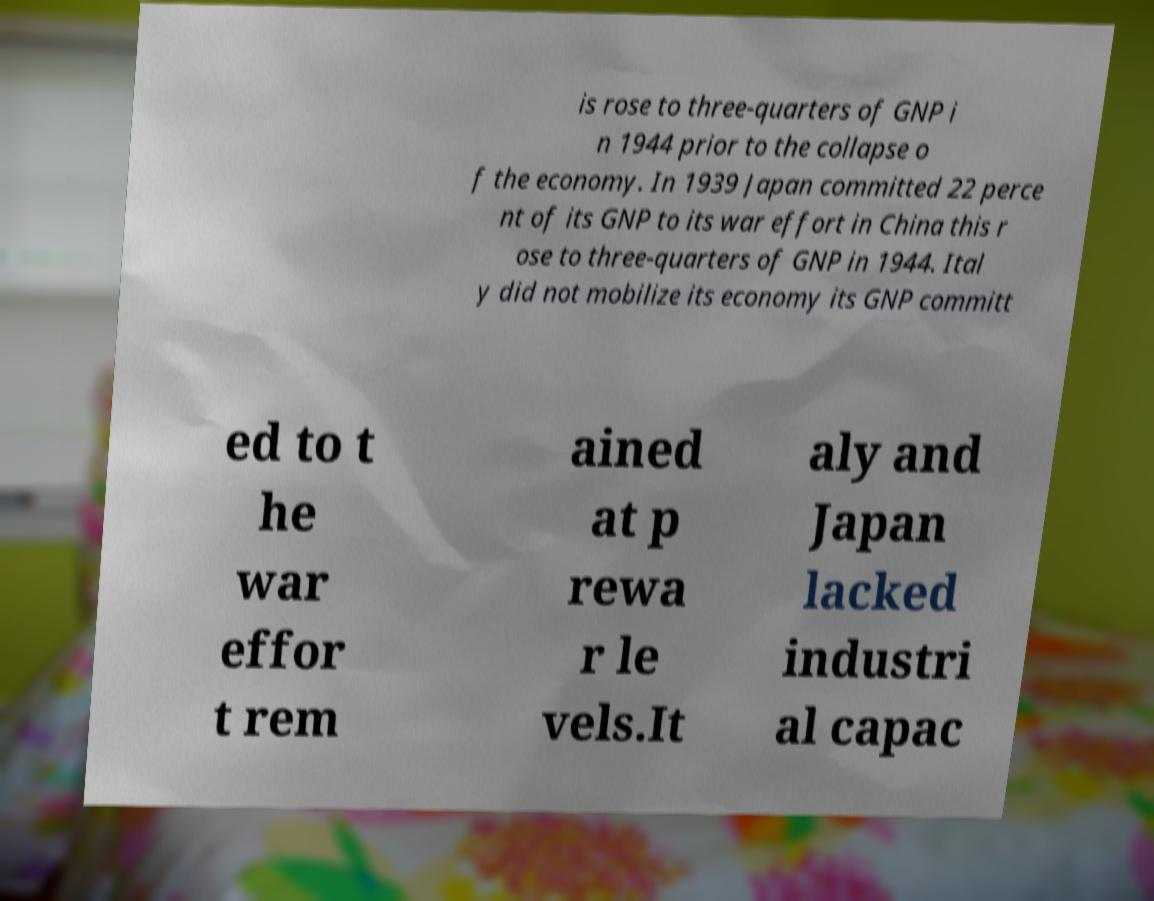Could you assist in decoding the text presented in this image and type it out clearly? is rose to three-quarters of GNP i n 1944 prior to the collapse o f the economy. In 1939 Japan committed 22 perce nt of its GNP to its war effort in China this r ose to three-quarters of GNP in 1944. Ital y did not mobilize its economy its GNP committ ed to t he war effor t rem ained at p rewa r le vels.It aly and Japan lacked industri al capac 